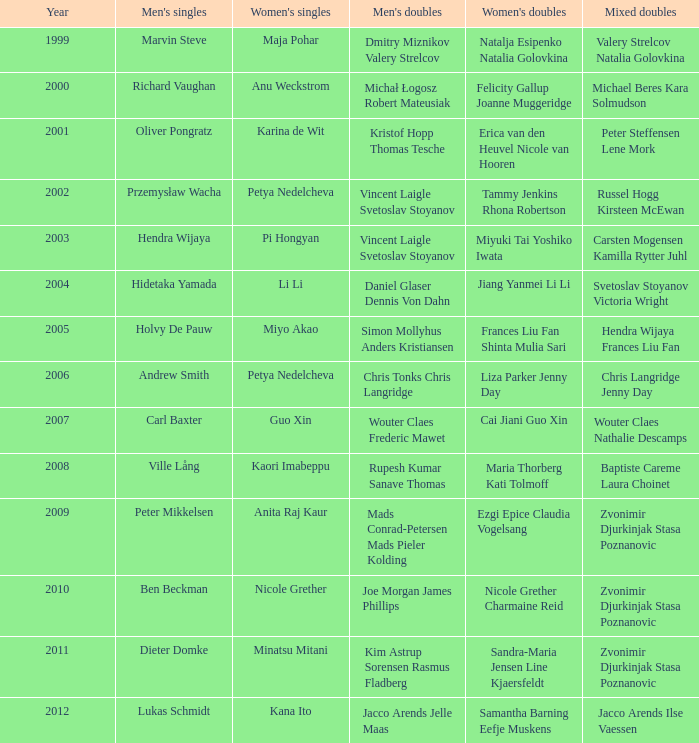Provide the earliest year that showcased pi hongyan in women's singles. 2003.0. 